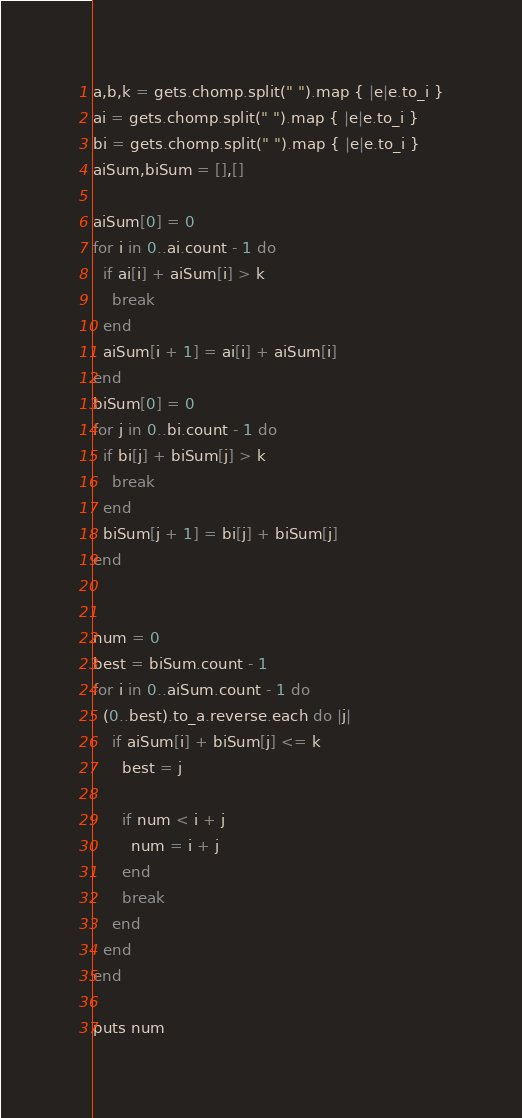Convert code to text. <code><loc_0><loc_0><loc_500><loc_500><_Ruby_>a,b,k = gets.chomp.split(" ").map { |e|e.to_i }
ai = gets.chomp.split(" ").map { |e|e.to_i }
bi = gets.chomp.split(" ").map { |e|e.to_i }
aiSum,biSum = [],[]

aiSum[0] = 0
for i in 0..ai.count - 1 do
  if ai[i] + aiSum[i] > k
    break
  end
  aiSum[i + 1] = ai[i] + aiSum[i]
end
biSum[0] = 0
for j in 0..bi.count - 1 do
  if bi[j] + biSum[j] > k
    break
  end
  biSum[j + 1] = bi[j] + biSum[j]
end


num = 0
best = biSum.count - 1
for i in 0..aiSum.count - 1 do
  (0..best).to_a.reverse.each do |j|
    if aiSum[i] + biSum[j] <= k
      best = j

      if num < i + j
        num = i + j
      end
      break
    end
  end
end

puts num
</code> 